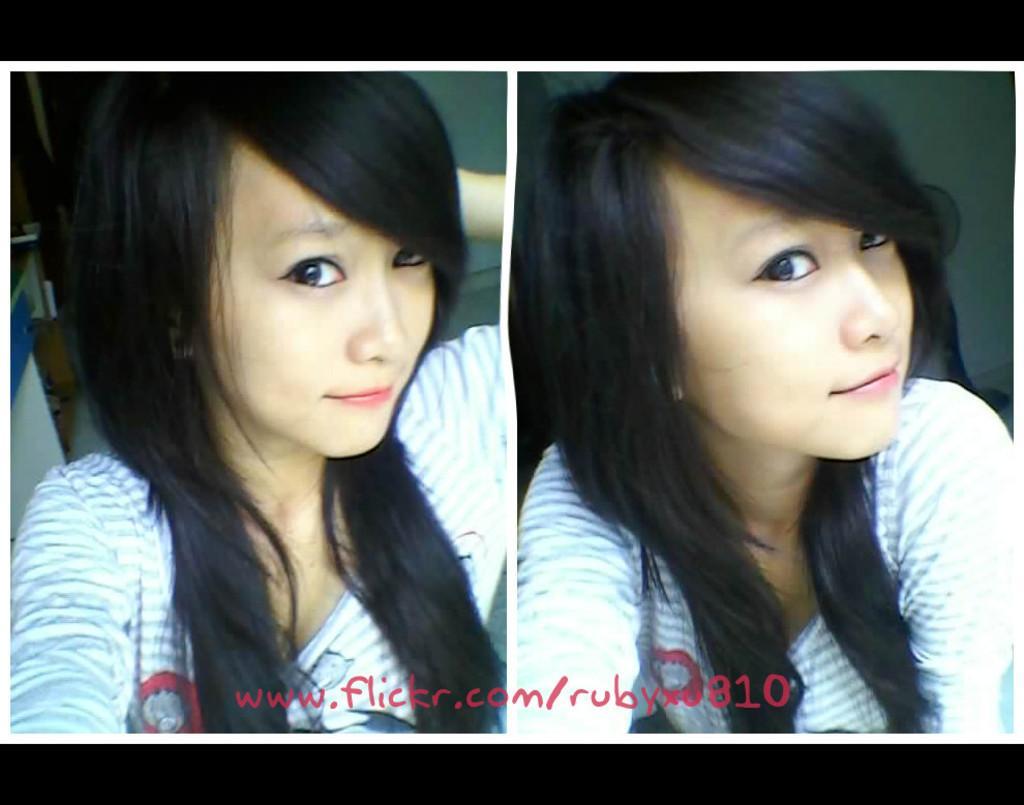Can you describe this image briefly? In this picture we can see collage of two images, in these pictures we can see a woman, at the bottom there is some text. 